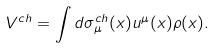<formula> <loc_0><loc_0><loc_500><loc_500>V ^ { c h } = \int d \sigma _ { \mu } ^ { c h } ( x ) u ^ { \mu } ( x ) \rho ( x ) .</formula> 